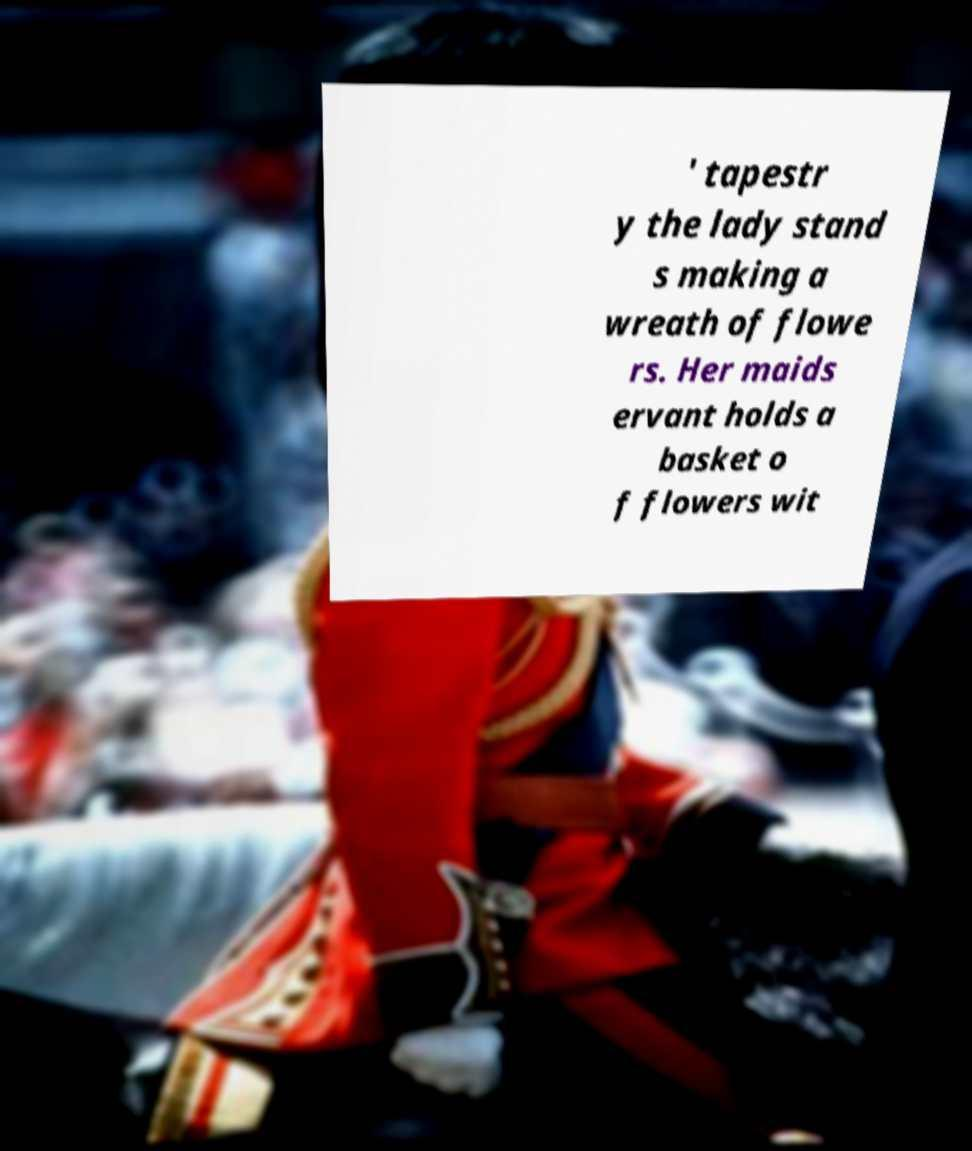For documentation purposes, I need the text within this image transcribed. Could you provide that? ' tapestr y the lady stand s making a wreath of flowe rs. Her maids ervant holds a basket o f flowers wit 